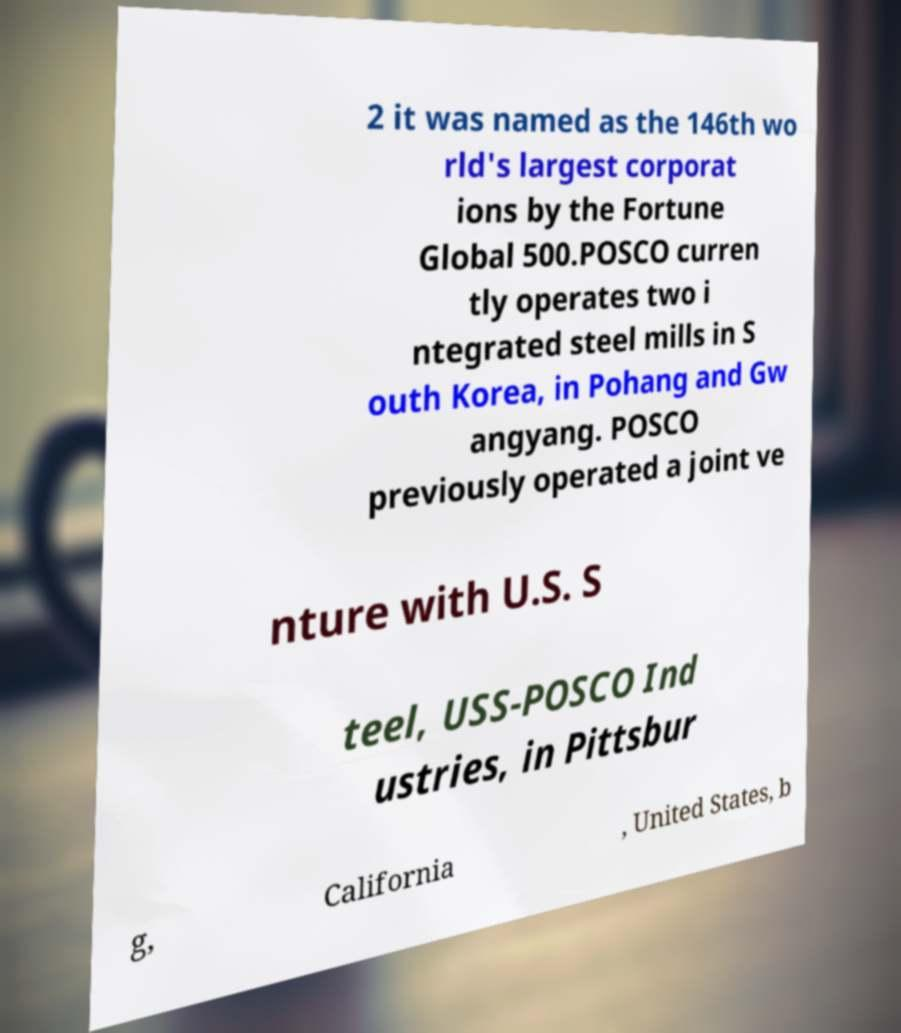For documentation purposes, I need the text within this image transcribed. Could you provide that? 2 it was named as the 146th wo rld's largest corporat ions by the Fortune Global 500.POSCO curren tly operates two i ntegrated steel mills in S outh Korea, in Pohang and Gw angyang. POSCO previously operated a joint ve nture with U.S. S teel, USS-POSCO Ind ustries, in Pittsbur g, California , United States, b 